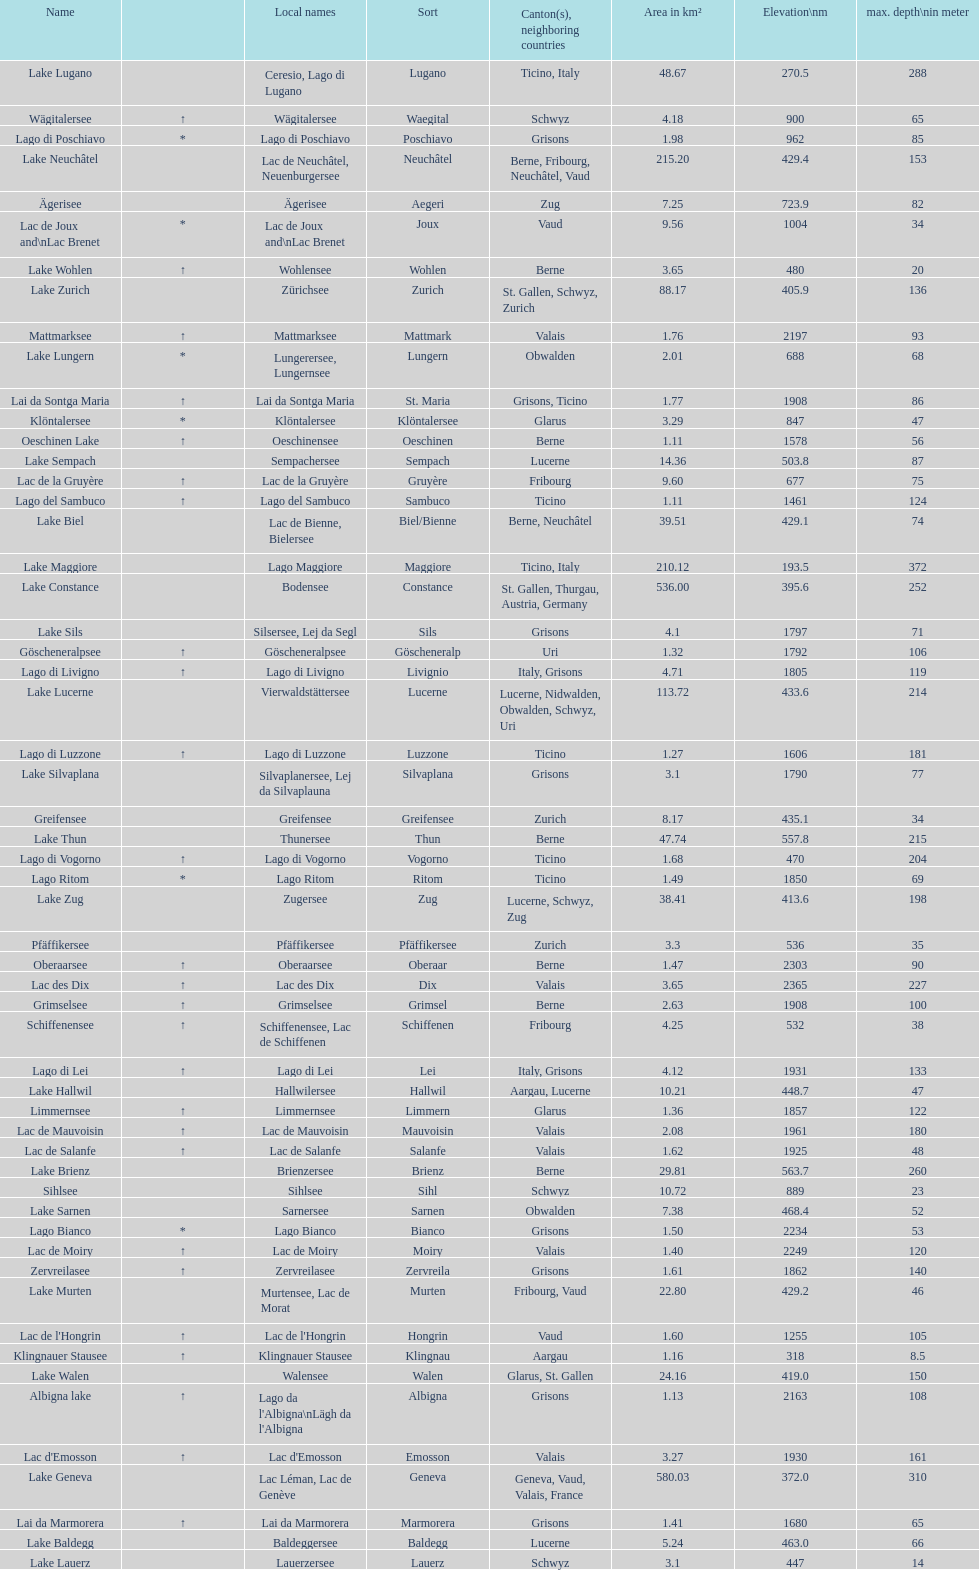Which is the only lake with a max depth of 372m? Lake Maggiore. 